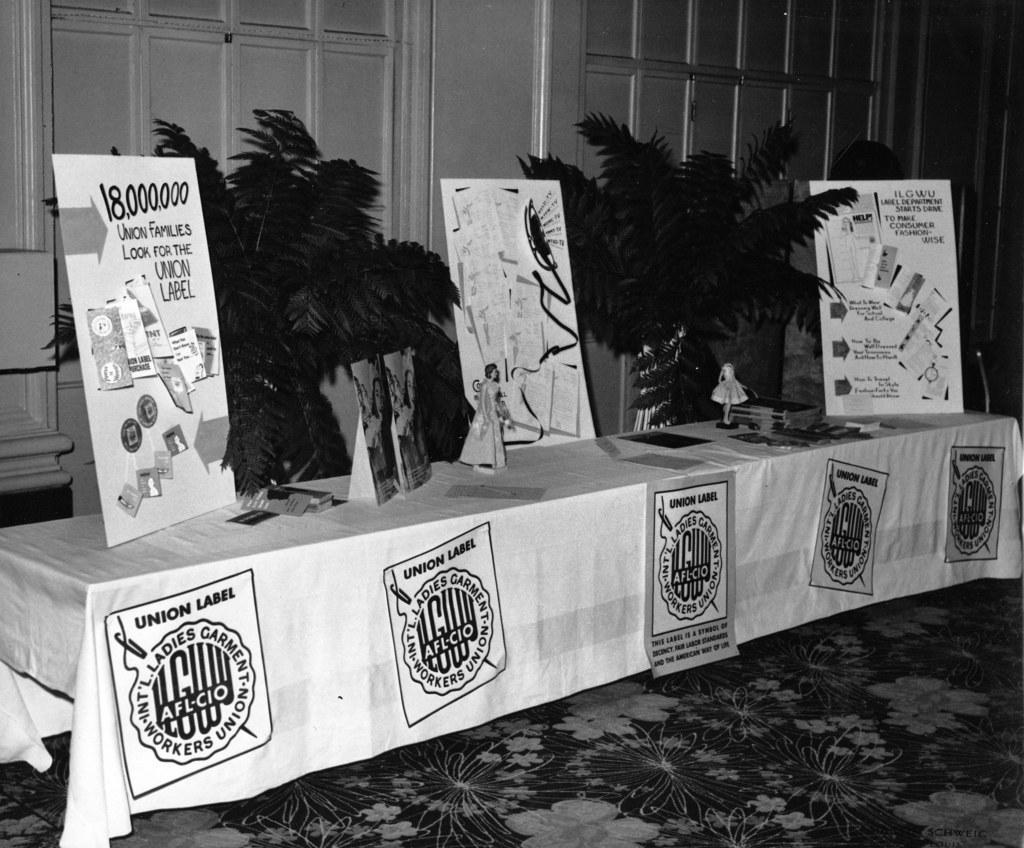How would you summarize this image in a sentence or two? In the picture we can see a table on it, we can see a cloth and on it we can see three boards with an advertisement and behind it, we can see two plants and behind it, we can see a wall and on the floor we can see a floor mat with flower designs on it. 